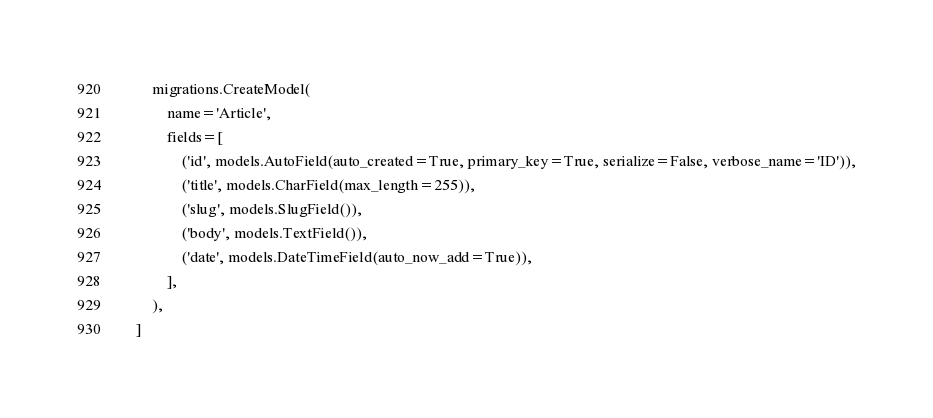Convert code to text. <code><loc_0><loc_0><loc_500><loc_500><_Python_>        migrations.CreateModel(
            name='Article',
            fields=[
                ('id', models.AutoField(auto_created=True, primary_key=True, serialize=False, verbose_name='ID')),
                ('title', models.CharField(max_length=255)),
                ('slug', models.SlugField()),
                ('body', models.TextField()),
                ('date', models.DateTimeField(auto_now_add=True)),
            ],
        ),
    ]
</code> 